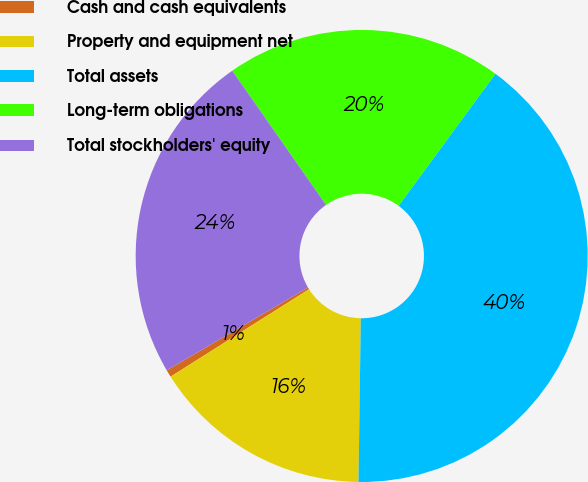Convert chart. <chart><loc_0><loc_0><loc_500><loc_500><pie_chart><fcel>Cash and cash equivalents<fcel>Property and equipment net<fcel>Total assets<fcel>Long-term obligations<fcel>Total stockholders' equity<nl><fcel>0.52%<fcel>15.81%<fcel>40.15%<fcel>19.78%<fcel>23.74%<nl></chart> 